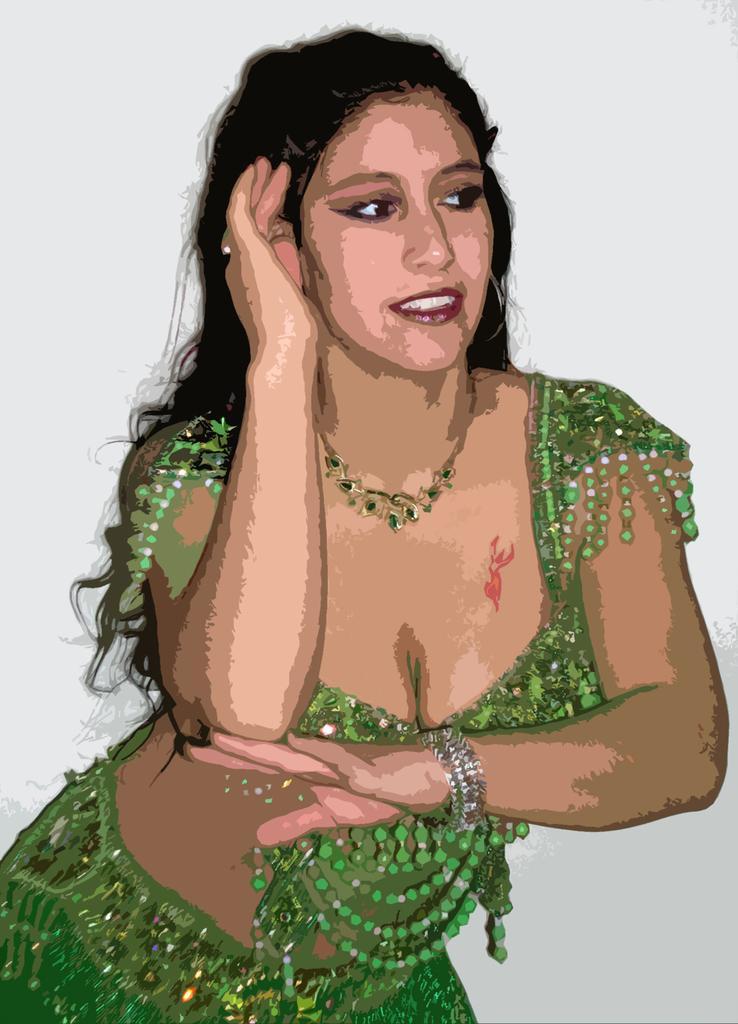In one or two sentences, can you explain what this image depicts? In this image, we can see the painting of a woman and there is a white background. 